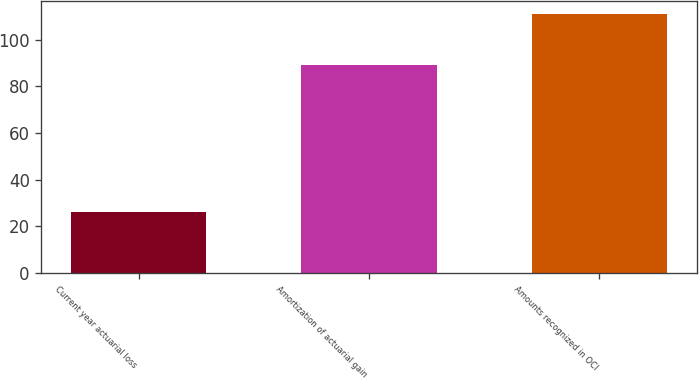Convert chart. <chart><loc_0><loc_0><loc_500><loc_500><bar_chart><fcel>Current year actuarial loss<fcel>Amortization of actuarial gain<fcel>Amounts recognized in OCI<nl><fcel>26<fcel>89<fcel>111<nl></chart> 